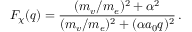<formula> <loc_0><loc_0><loc_500><loc_500>F _ { \chi } { ( q ) } = \frac { ( m _ { v } / m _ { e } ) ^ { 2 } + \alpha ^ { 2 } } { ( m _ { v } / m _ { e } ) ^ { 2 } + ( \alpha a _ { 0 } q ) ^ { 2 } } \, .</formula> 